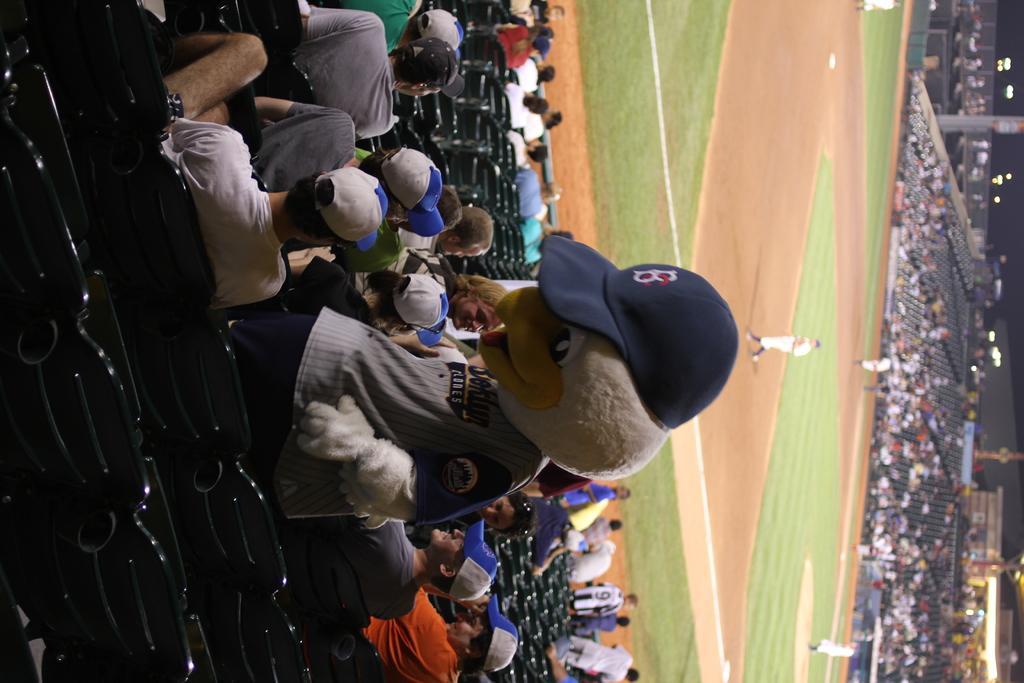Please provide a concise description of this image. There are groups of people sitting and few people standing. This looks like a ground. These are the empty chairs. I think this picture was taken in the stadium. Here is a person with a fancy dress. 